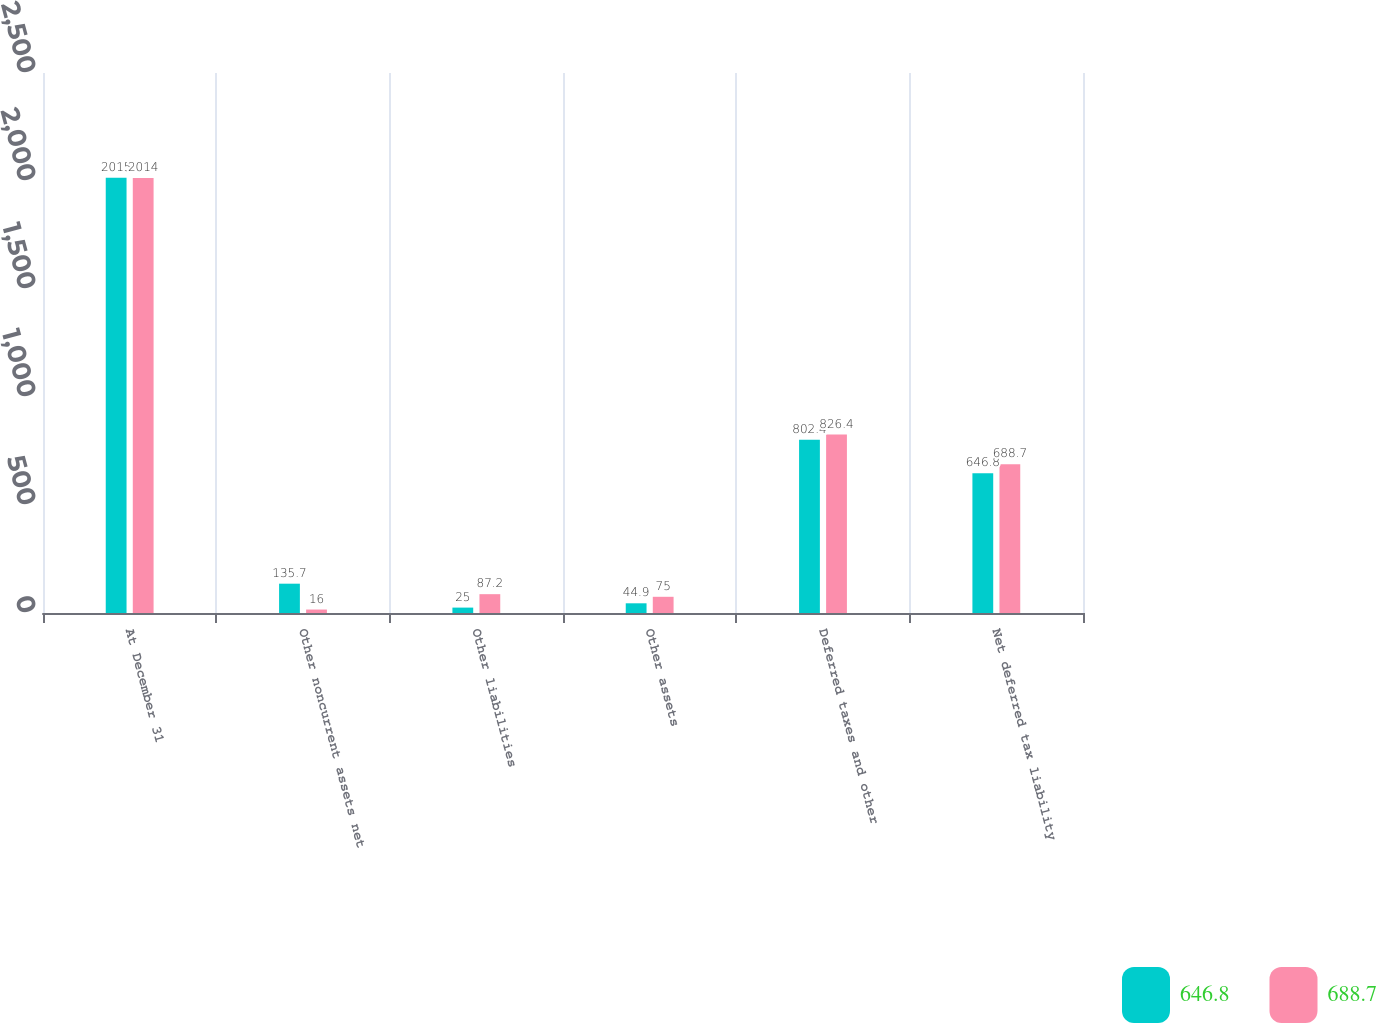Convert chart to OTSL. <chart><loc_0><loc_0><loc_500><loc_500><stacked_bar_chart><ecel><fcel>At December 31<fcel>Other noncurrent assets net<fcel>Other liabilities<fcel>Other assets<fcel>Deferred taxes and other<fcel>Net deferred tax liability<nl><fcel>646.8<fcel>2015<fcel>135.7<fcel>25<fcel>44.9<fcel>802.4<fcel>646.8<nl><fcel>688.7<fcel>2014<fcel>16<fcel>87.2<fcel>75<fcel>826.4<fcel>688.7<nl></chart> 